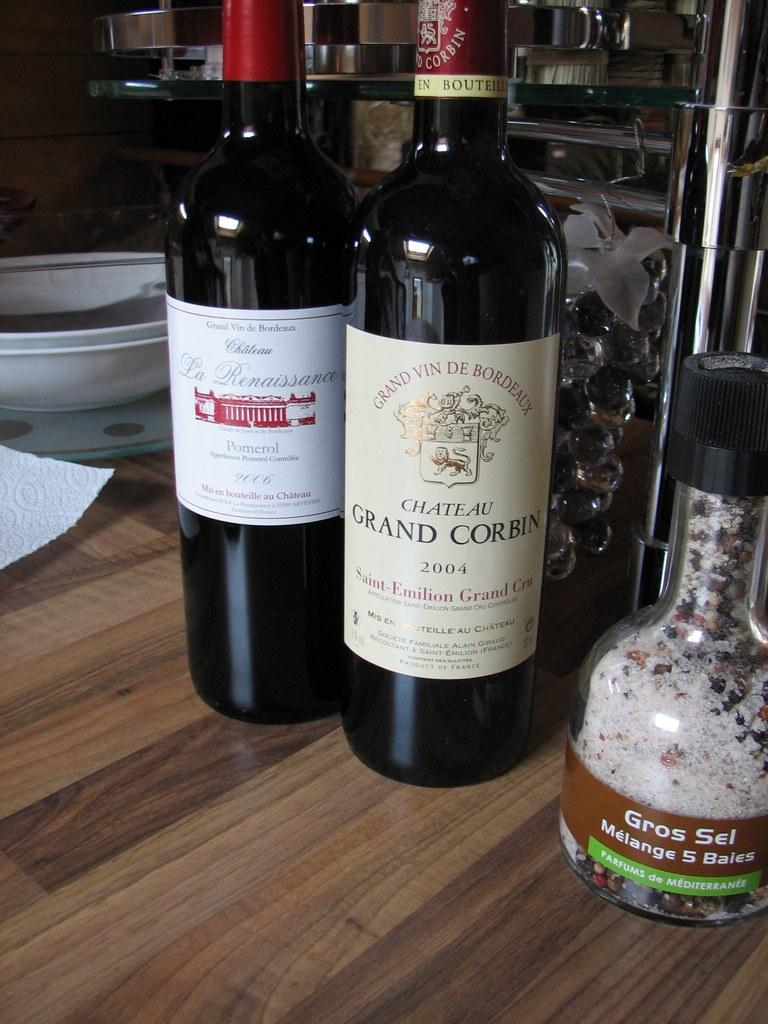Provide a one-sentence caption for the provided image. A bottle of Chateau Gran Corbin fro 2004 sits on a wooden table next to another bottle of wine. 